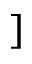Convert formula to latex. <formula><loc_0><loc_0><loc_500><loc_500>]</formula> 